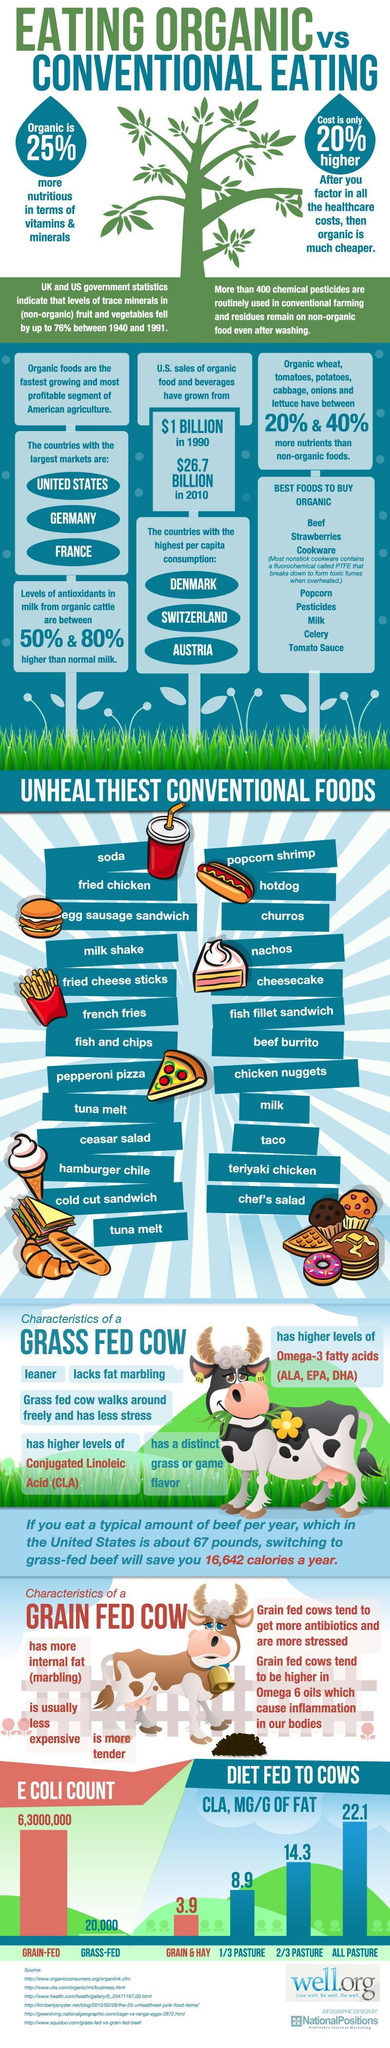What has been the growth in sales of organic food and beverages from 1990 to 2010?
Answer the question with a short phrase. $ 25.7 million What is the percentage difference of CLA present in grass fed cows and grain fed cows? 18.2% Which are the non-consumable items listed under the best foods to buy? Cookware, Pesticides What is the difference in E Coli count of Grain-fed and Grass-Fed cows? 62,980,000 How many consumable foods are listed in the best organic food? 6 